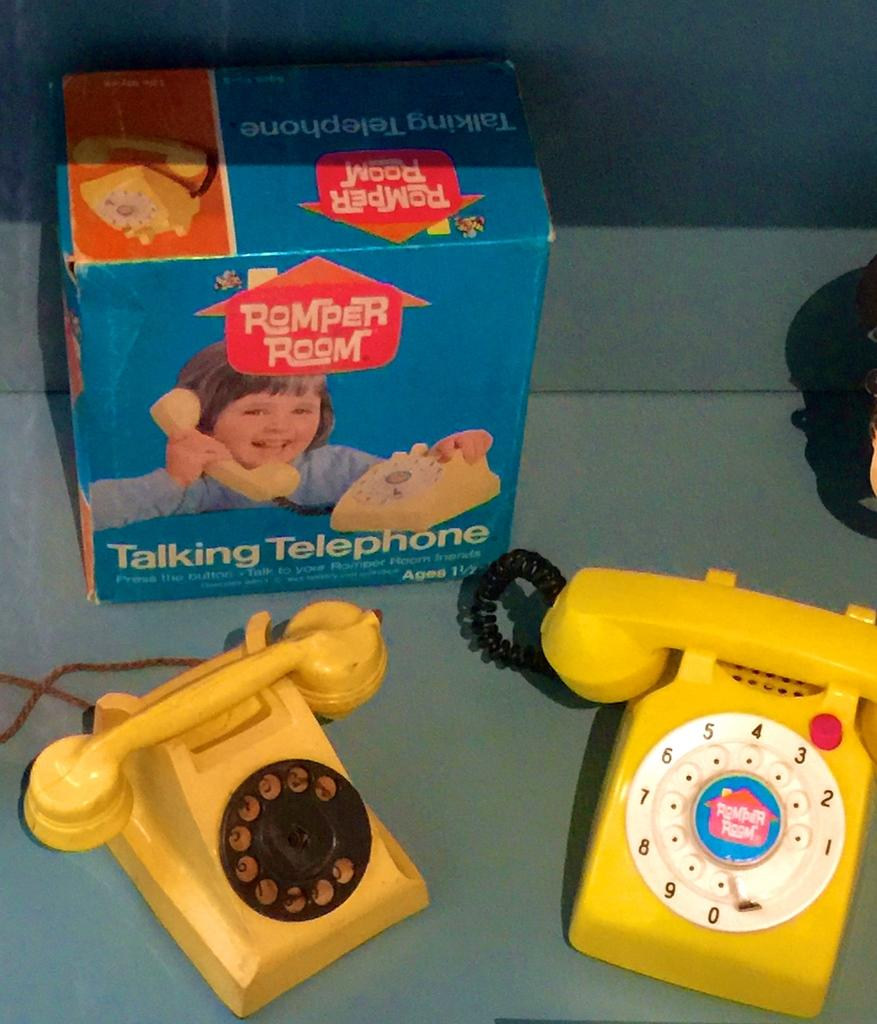<image>
Relay a brief, clear account of the picture shown. a couple toy phones with a box that says talking telephone 